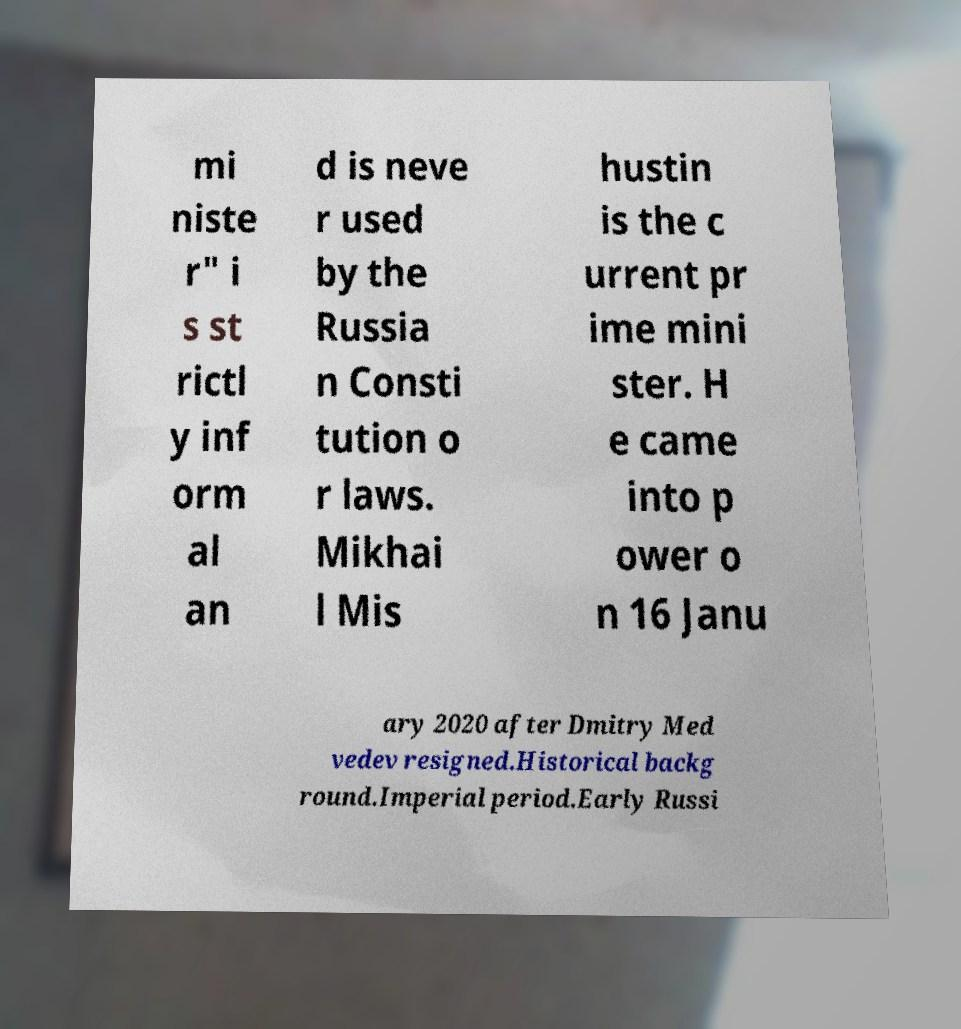I need the written content from this picture converted into text. Can you do that? mi niste r" i s st rictl y inf orm al an d is neve r used by the Russia n Consti tution o r laws. Mikhai l Mis hustin is the c urrent pr ime mini ster. H e came into p ower o n 16 Janu ary 2020 after Dmitry Med vedev resigned.Historical backg round.Imperial period.Early Russi 